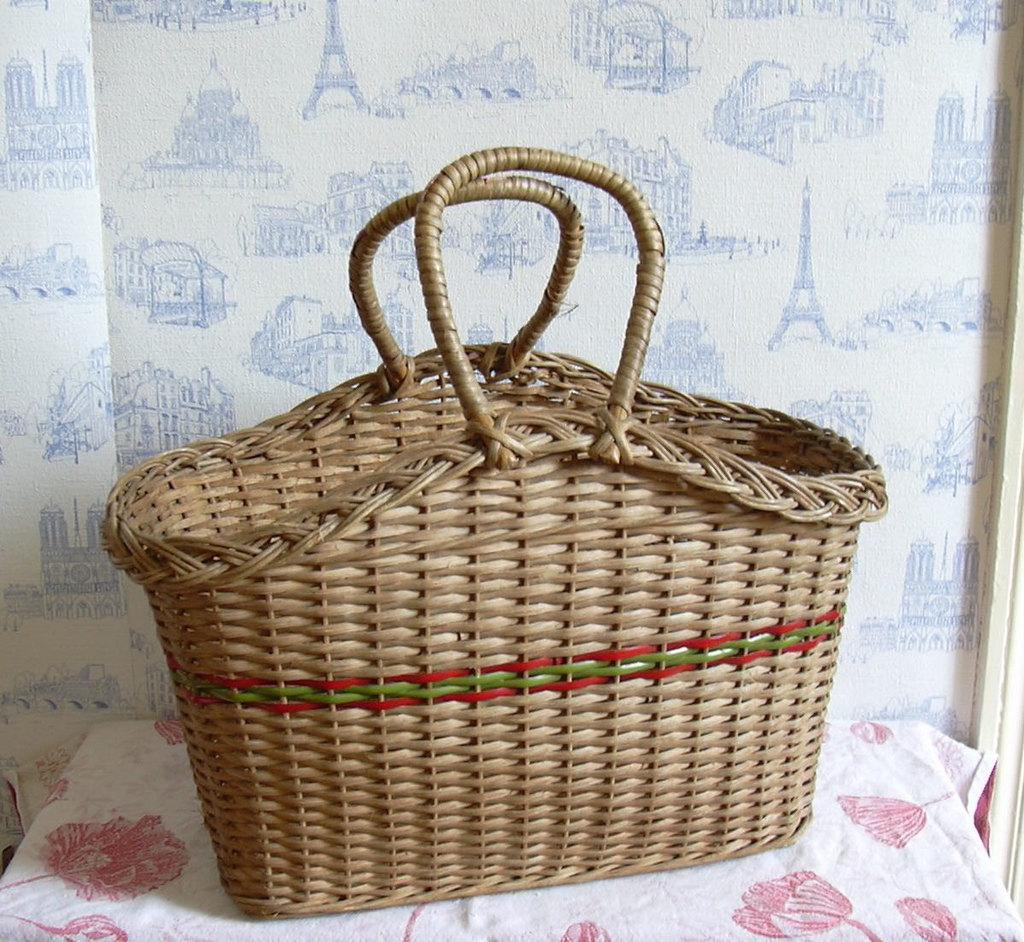What object is present in the image? There is a bag in the image. What colors can be seen on the bag? The bag has brown, red, and green colors. On what surface is the bag placed? The bag is on a white and red cloth. What can be seen in the background of the image? There is a wall in the background of the image. How many tickets does the representative need to purchase for the event? There is no mention of tickets, an event, or a representative in the image, so it is impossible to answer this question. 